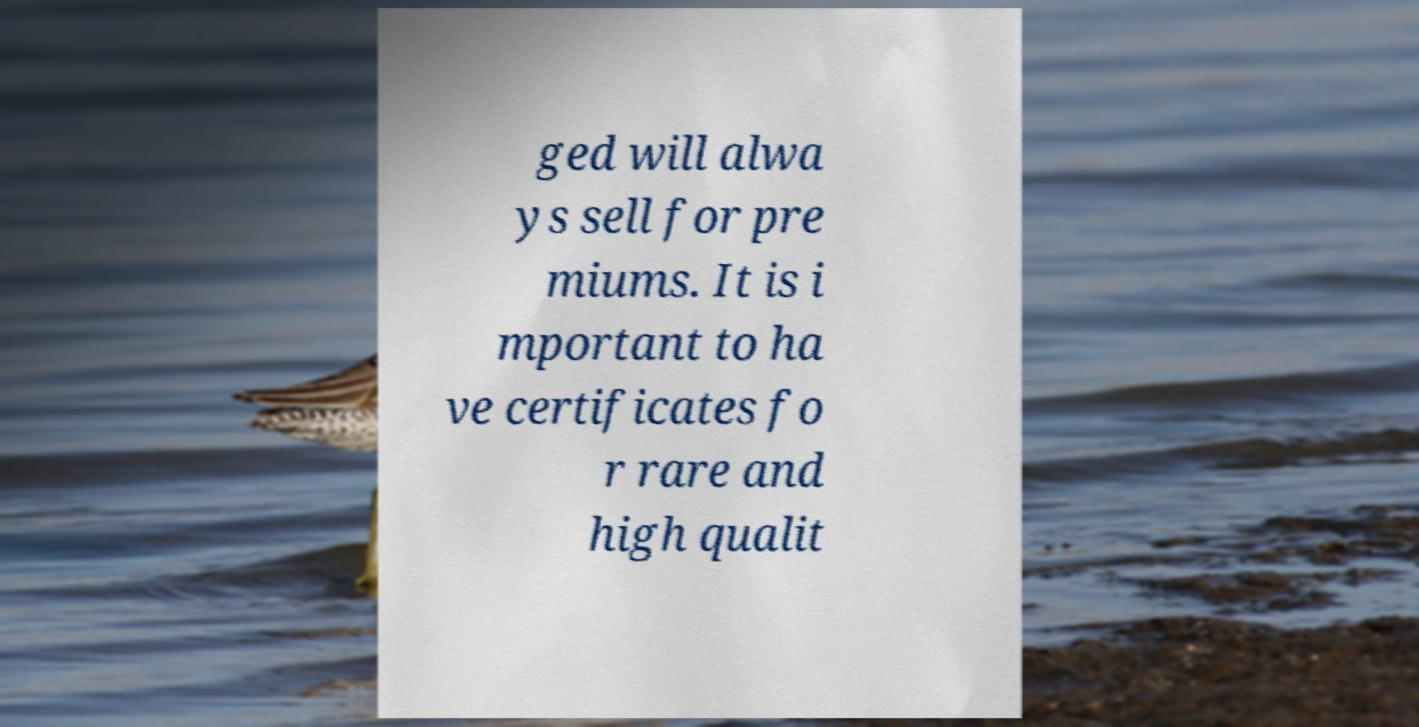Could you extract and type out the text from this image? ged will alwa ys sell for pre miums. It is i mportant to ha ve certificates fo r rare and high qualit 